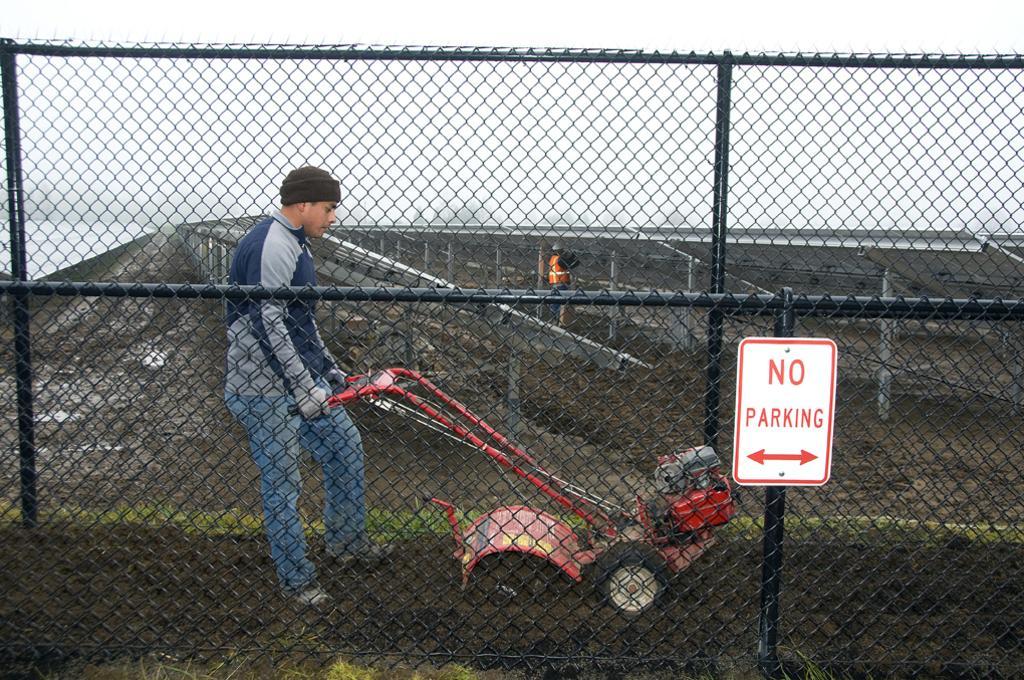Could you give a brief overview of what you see in this image? In the foreground of the picture we can see fencing, board, person, soil, grass and a machine. In the middle of the picture we can see railing, soil and other objects. In the background it is sky. 